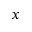<formula> <loc_0><loc_0><loc_500><loc_500>x</formula> 